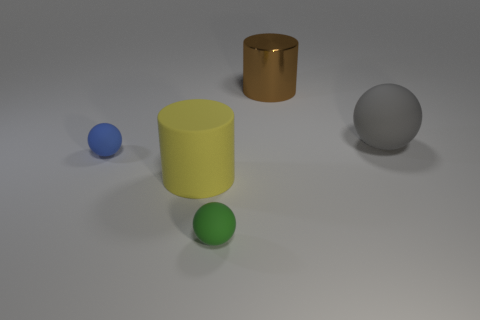Are there any other things that are the same material as the big brown thing?
Your answer should be compact. No. The small blue object has what shape?
Offer a very short reply. Sphere. What is the material of the cylinder on the left side of the object that is behind the large rubber sphere?
Your answer should be compact. Rubber. How many other things are the same material as the small green ball?
Your answer should be very brief. 3. There is another cylinder that is the same size as the rubber cylinder; what is its material?
Your answer should be compact. Metal. Is the number of blue rubber things that are on the left side of the gray rubber ball greater than the number of small blue matte spheres to the right of the brown metal cylinder?
Provide a short and direct response. Yes. Are there any other big objects that have the same shape as the large yellow object?
Provide a short and direct response. Yes. There is another thing that is the same size as the blue rubber object; what shape is it?
Give a very brief answer. Sphere. There is a tiny thing in front of the blue rubber sphere; what shape is it?
Provide a short and direct response. Sphere. Are there fewer large objects that are right of the small green rubber sphere than matte objects that are on the right side of the small blue ball?
Ensure brevity in your answer.  Yes. 